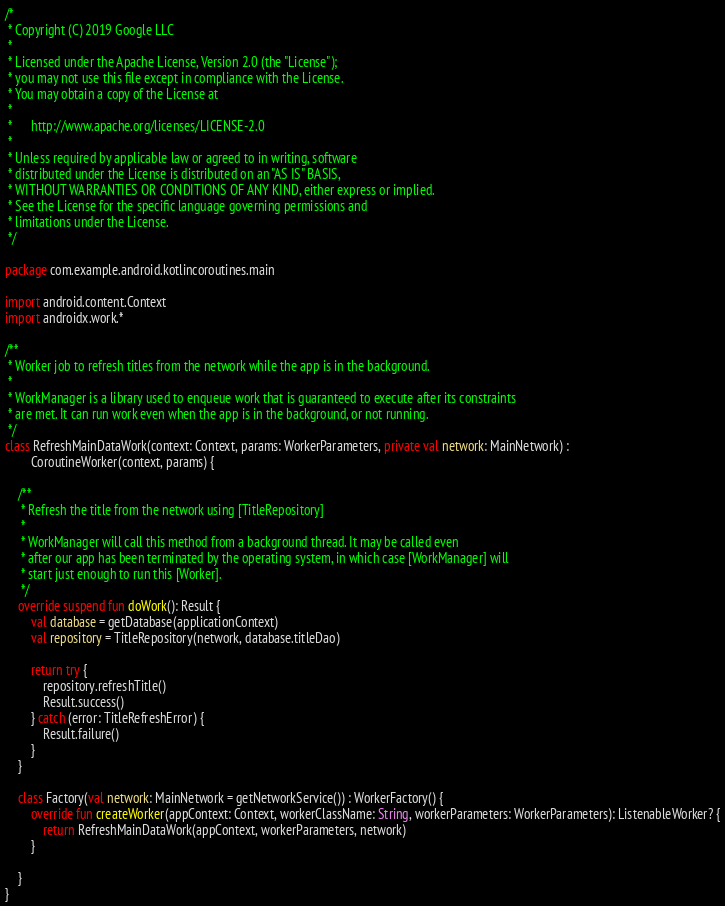<code> <loc_0><loc_0><loc_500><loc_500><_Kotlin_>/*
 * Copyright (C) 2019 Google LLC
 *
 * Licensed under the Apache License, Version 2.0 (the "License");
 * you may not use this file except in compliance with the License.
 * You may obtain a copy of the License at
 *
 *      http://www.apache.org/licenses/LICENSE-2.0
 *
 * Unless required by applicable law or agreed to in writing, software
 * distributed under the License is distributed on an "AS IS" BASIS,
 * WITHOUT WARRANTIES OR CONDITIONS OF ANY KIND, either express or implied.
 * See the License for the specific language governing permissions and
 * limitations under the License.
 */

package com.example.android.kotlincoroutines.main

import android.content.Context
import androidx.work.*

/**
 * Worker job to refresh titles from the network while the app is in the background.
 *
 * WorkManager is a library used to enqueue work that is guaranteed to execute after its constraints
 * are met. It can run work even when the app is in the background, or not running.
 */
class RefreshMainDataWork(context: Context, params: WorkerParameters, private val network: MainNetwork) :
        CoroutineWorker(context, params) {

    /**
     * Refresh the title from the network using [TitleRepository]
     *
     * WorkManager will call this method from a background thread. It may be called even
     * after our app has been terminated by the operating system, in which case [WorkManager] will
     * start just enough to run this [Worker].
     */
    override suspend fun doWork(): Result {
        val database = getDatabase(applicationContext)
        val repository = TitleRepository(network, database.titleDao)

        return try {
            repository.refreshTitle()
            Result.success()
        } catch (error: TitleRefreshError) {
            Result.failure()
        }
    }

    class Factory(val network: MainNetwork = getNetworkService()) : WorkerFactory() {
        override fun createWorker(appContext: Context, workerClassName: String, workerParameters: WorkerParameters): ListenableWorker? {
            return RefreshMainDataWork(appContext, workerParameters, network)
        }

    }
}</code> 